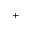<formula> <loc_0><loc_0><loc_500><loc_500>^ { + }</formula> 